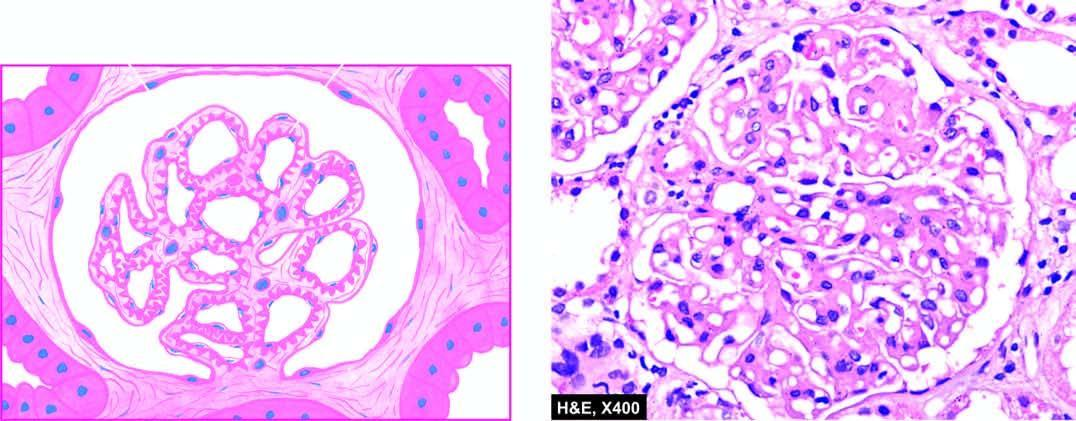re the cytoplasm normocellular?
Answer the question using a single word or phrase. No 